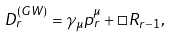Convert formula to latex. <formula><loc_0><loc_0><loc_500><loc_500>D ^ { ( G W ) } _ { r } = \gamma _ { \mu } p ^ { \mu } _ { r } + \square R _ { r - 1 } ,</formula> 